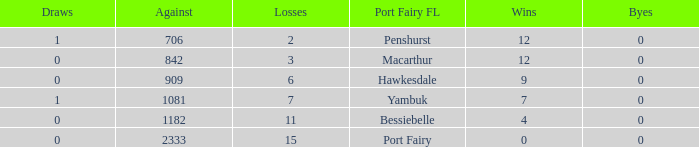How many draws when the Port Fairy FL is Hawkesdale and there are more than 9 wins? None. 